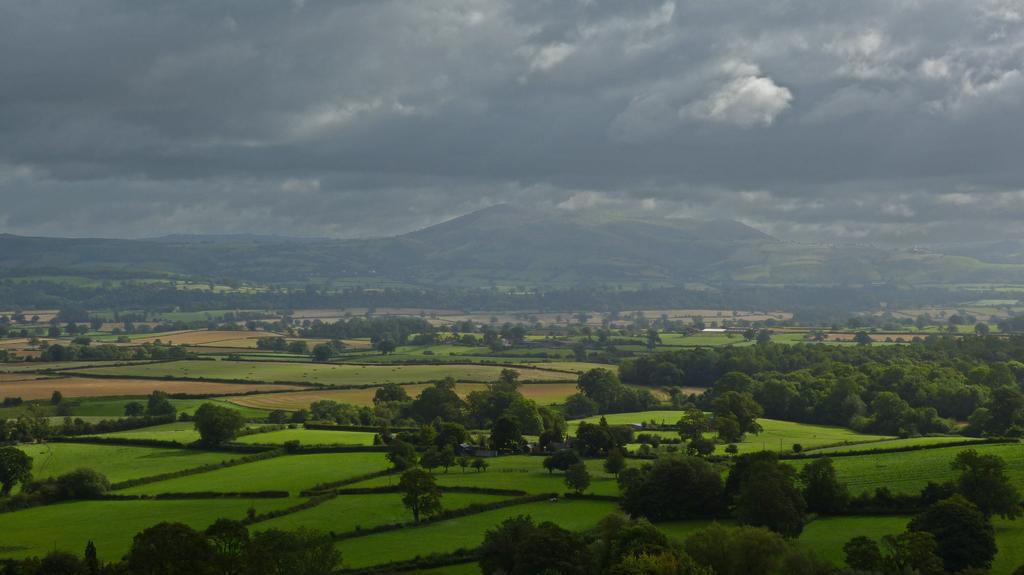What can be seen in the foreground of the picture? There are trees and fields in the foreground of the picture. What can be seen in the background of the picture? There are fields, trees, and hills in the background of the picture. What is the condition of the sky in the picture? The sky is cloudy in the picture. How many dimes are scattered across the fields in the image? There are no dimes present in the image; it features trees, fields, and hills. What type of structure can be seen in the background of the image? There is no structure present in the image; it features trees, fields, and hills. 